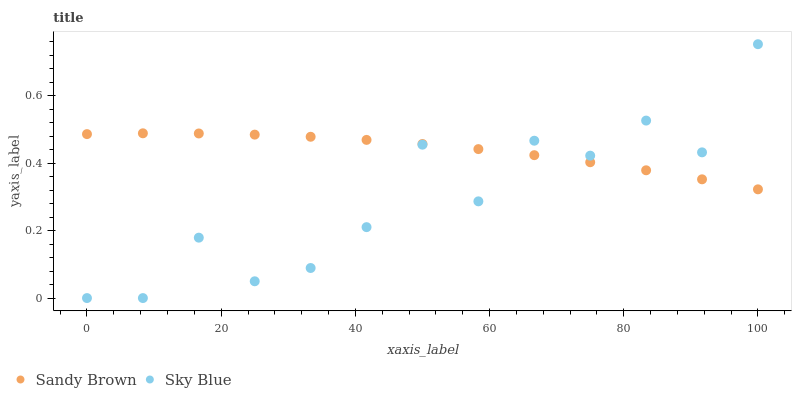Does Sky Blue have the minimum area under the curve?
Answer yes or no. Yes. Does Sandy Brown have the maximum area under the curve?
Answer yes or no. Yes. Does Sandy Brown have the minimum area under the curve?
Answer yes or no. No. Is Sandy Brown the smoothest?
Answer yes or no. Yes. Is Sky Blue the roughest?
Answer yes or no. Yes. Is Sandy Brown the roughest?
Answer yes or no. No. Does Sky Blue have the lowest value?
Answer yes or no. Yes. Does Sandy Brown have the lowest value?
Answer yes or no. No. Does Sky Blue have the highest value?
Answer yes or no. Yes. Does Sandy Brown have the highest value?
Answer yes or no. No. Does Sandy Brown intersect Sky Blue?
Answer yes or no. Yes. Is Sandy Brown less than Sky Blue?
Answer yes or no. No. Is Sandy Brown greater than Sky Blue?
Answer yes or no. No. 